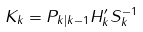<formula> <loc_0><loc_0><loc_500><loc_500>K _ { k } = P _ { k | k - 1 } H _ { k } ^ { \prime } S _ { k } ^ { - 1 }</formula> 